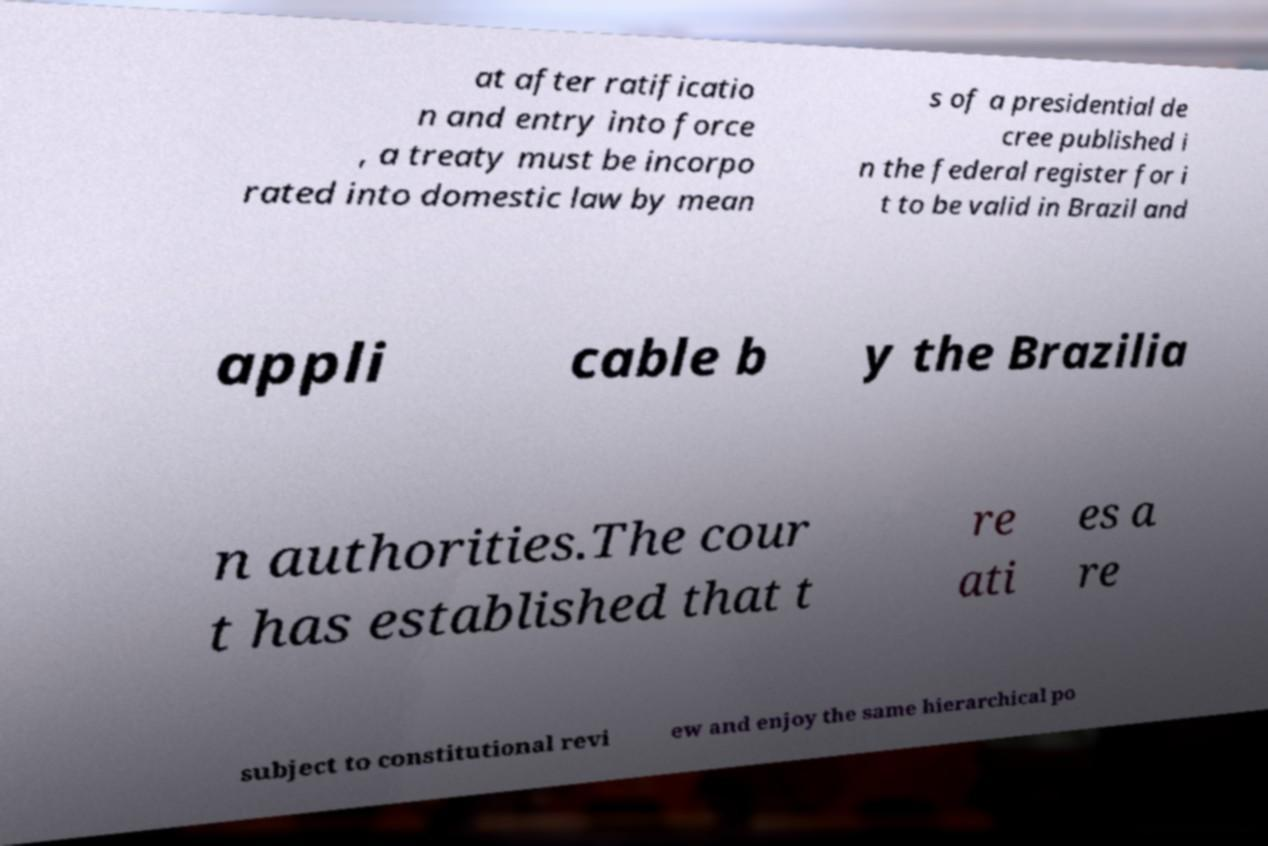For documentation purposes, I need the text within this image transcribed. Could you provide that? at after ratificatio n and entry into force , a treaty must be incorpo rated into domestic law by mean s of a presidential de cree published i n the federal register for i t to be valid in Brazil and appli cable b y the Brazilia n authorities.The cour t has established that t re ati es a re subject to constitutional revi ew and enjoy the same hierarchical po 